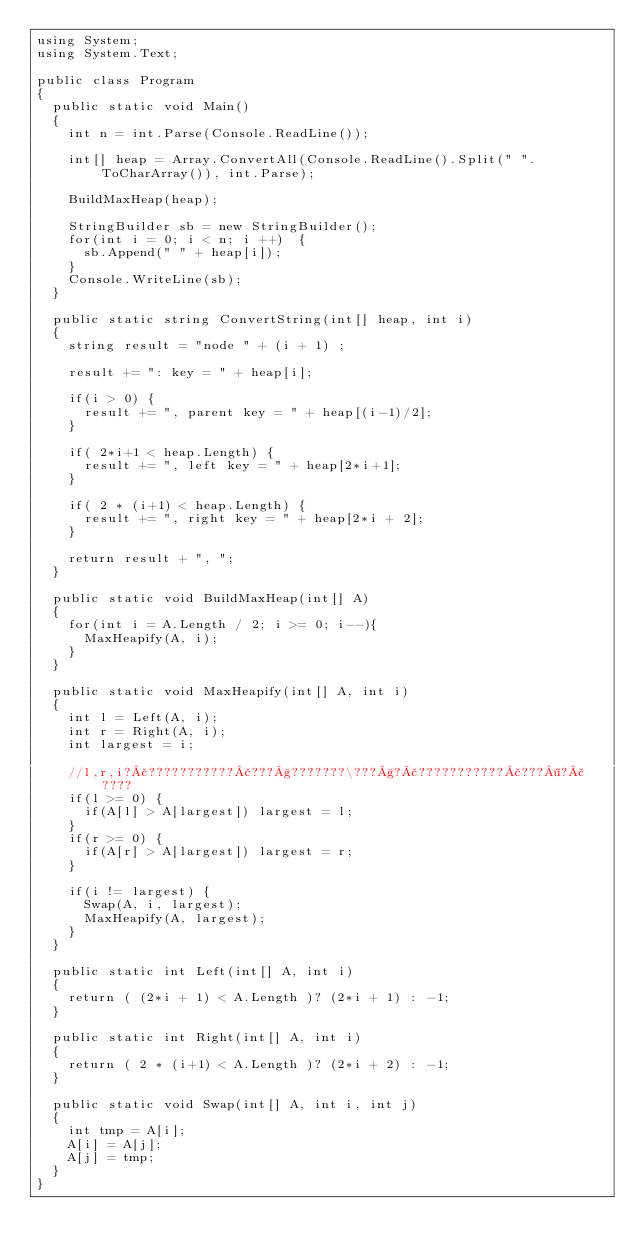<code> <loc_0><loc_0><loc_500><loc_500><_C#_>using System;
using System.Text;
					
public class Program
{
	public static void Main()
	{
		int n = int.Parse(Console.ReadLine());
		
		int[] heap = Array.ConvertAll(Console.ReadLine().Split(" ".ToCharArray()), int.Parse);
		
		BuildMaxHeap(heap);
		
		StringBuilder sb = new StringBuilder();
		for(int i = 0; i < n; i ++)  {
			sb.Append(" " + heap[i]);
		}
		Console.WriteLine(sb);
	}
	
	public static string ConvertString(int[] heap, int i)
	{
		string result = "node " + (i + 1) ;
		
		result += ": key = " + heap[i];
		
		if(i > 0) {
			result += ", parent key = " + heap[(i-1)/2];
		}
		
		if( 2*i+1 < heap.Length) {
			result += ", left key = " + heap[2*i+1];
		}
		
		if( 2 * (i+1) < heap.Length) {
			result += ", right key = " + heap[2*i + 2];
		}
		
		return result + ", ";
	}
	
	public static void BuildMaxHeap(int[] A)
	{
		for(int i = A.Length / 2; i >= 0; i--){
			MaxHeapify(A, i);
		}
	}
	
	public static void MaxHeapify(int[] A, int i)
	{
		int l = Left(A, i);
		int r = Right(A, i);
		int largest = i;
		
		//l,r,i?£???????????£???§???????\???§?£???????????£???¶?£????
		if(l >= 0) {
			if(A[l] > A[largest]) largest = l;	
		}
		if(r >= 0) {
			if(A[r] > A[largest]) largest = r;
		}
		
		if(i != largest) {
			Swap(A, i, largest);
			MaxHeapify(A, largest);
		}
	}
	
	public static int Left(int[] A, int i)
	{	
		return ( (2*i + 1) < A.Length )? (2*i + 1) : -1;
	}
	
	public static int Right(int[] A, int i)
	{	
		return ( 2 * (i+1) < A.Length )? (2*i + 2) : -1;
	}
	
	public static void Swap(int[] A, int i, int j)
	{
		int tmp = A[i];
		A[i] = A[j];
		A[j] = tmp;
	}
}</code> 